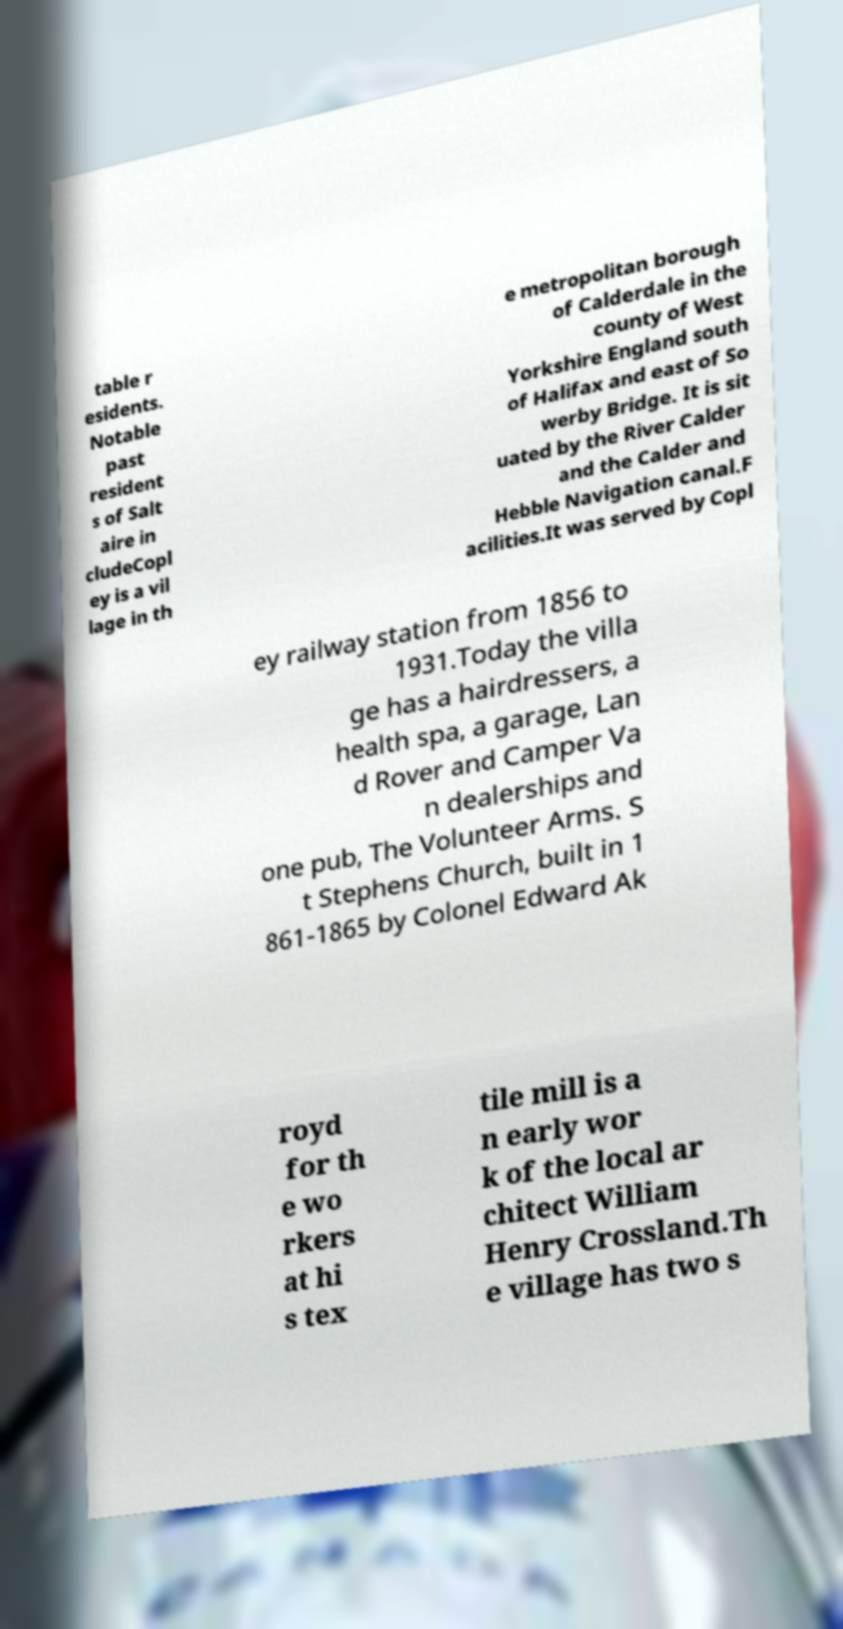Can you read and provide the text displayed in the image?This photo seems to have some interesting text. Can you extract and type it out for me? table r esidents. Notable past resident s of Salt aire in cludeCopl ey is a vil lage in th e metropolitan borough of Calderdale in the county of West Yorkshire England south of Halifax and east of So werby Bridge. It is sit uated by the River Calder and the Calder and Hebble Navigation canal.F acilities.It was served by Copl ey railway station from 1856 to 1931.Today the villa ge has a hairdressers, a health spa, a garage, Lan d Rover and Camper Va n dealerships and one pub, The Volunteer Arms. S t Stephens Church, built in 1 861-1865 by Colonel Edward Ak royd for th e wo rkers at hi s tex tile mill is a n early wor k of the local ar chitect William Henry Crossland.Th e village has two s 